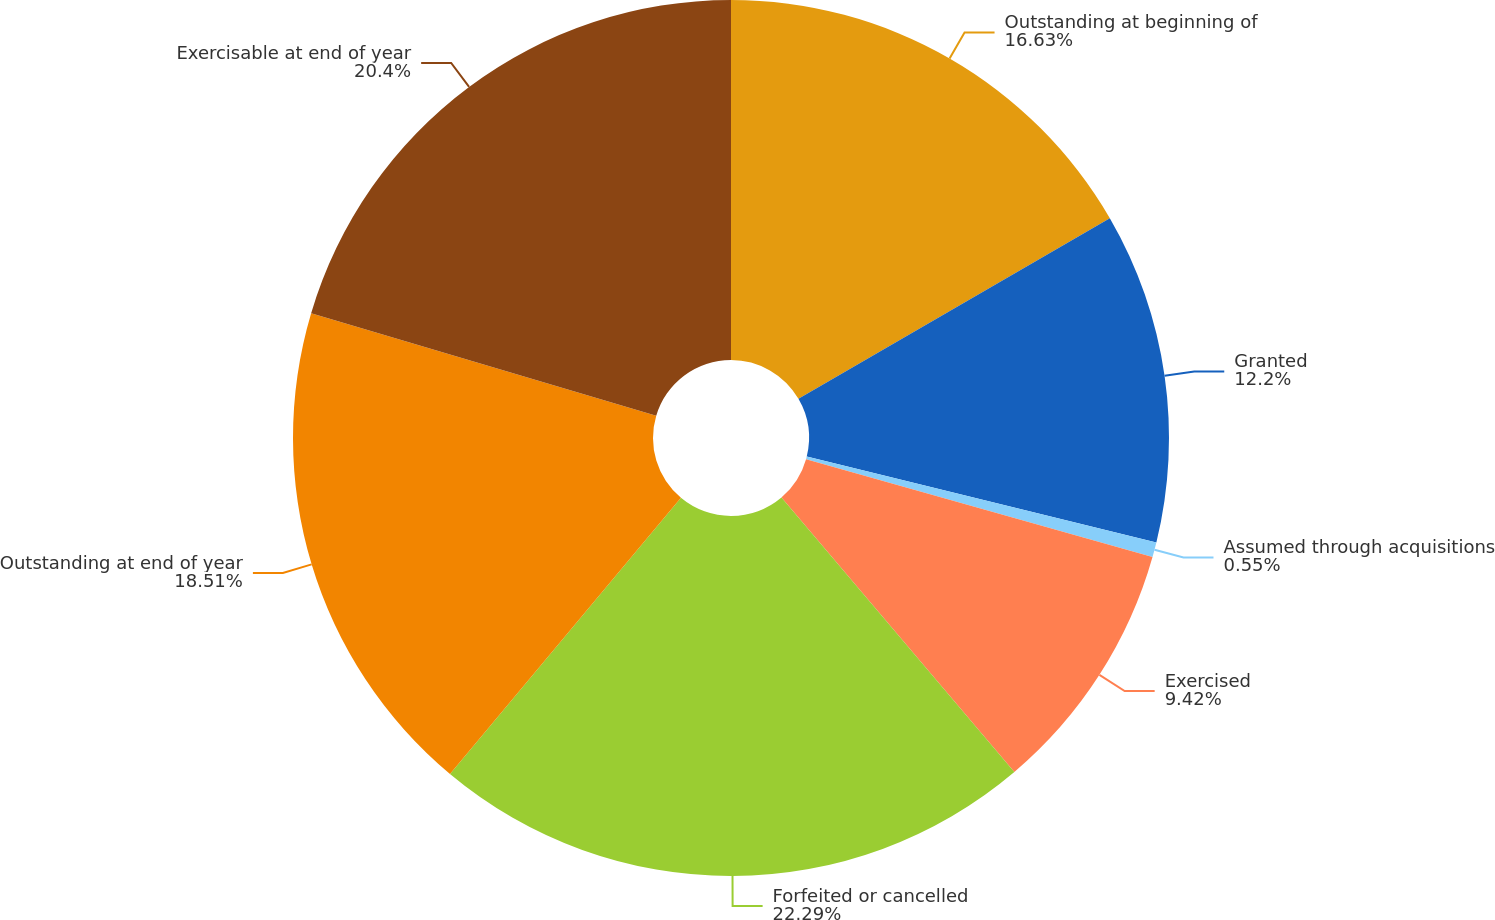Convert chart. <chart><loc_0><loc_0><loc_500><loc_500><pie_chart><fcel>Outstanding at beginning of<fcel>Granted<fcel>Assumed through acquisitions<fcel>Exercised<fcel>Forfeited or cancelled<fcel>Outstanding at end of year<fcel>Exercisable at end of year<nl><fcel>16.63%<fcel>12.2%<fcel>0.55%<fcel>9.42%<fcel>22.28%<fcel>18.51%<fcel>20.4%<nl></chart> 